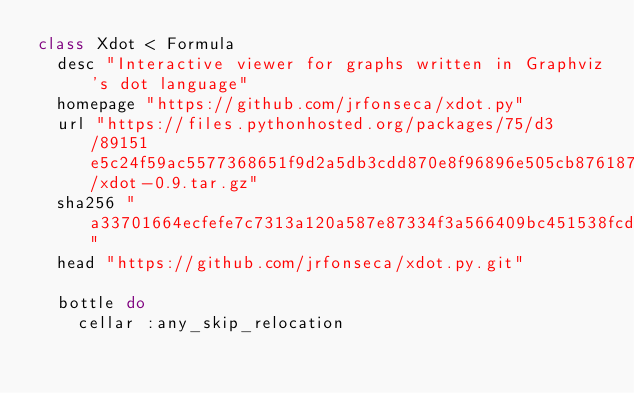Convert code to text. <code><loc_0><loc_0><loc_500><loc_500><_Ruby_>class Xdot < Formula
  desc "Interactive viewer for graphs written in Graphviz's dot language"
  homepage "https://github.com/jrfonseca/xdot.py"
  url "https://files.pythonhosted.org/packages/75/d3/89151e5c24f59ac5577368651f9d2a5db3cdd870e8f96896e505cb876187/xdot-0.9.tar.gz"
  sha256 "a33701664ecfefe7c7313a120a587e87334f3a566409bc451538fcde5edd6907"
  head "https://github.com/jrfonseca/xdot.py.git"

  bottle do
    cellar :any_skip_relocation</code> 